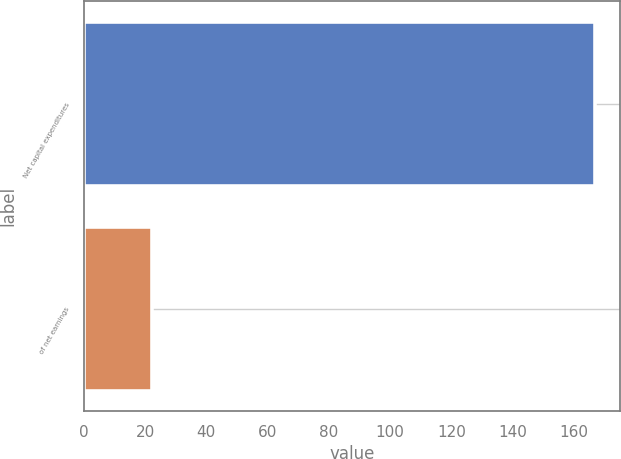Convert chart to OTSL. <chart><loc_0><loc_0><loc_500><loc_500><bar_chart><fcel>Net capital expenditures<fcel>of net earnings<nl><fcel>166.8<fcel>22.2<nl></chart> 